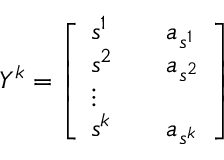<formula> <loc_0><loc_0><loc_500><loc_500>\begin{array} { r } { Y ^ { k } = \left [ \begin{array} { l l l } { s ^ { 1 } } & { a _ { s ^ { 1 } } } \\ { s ^ { 2 } } & { a _ { s ^ { 2 } } } \\ { \vdots } \\ { s ^ { k } } & { a _ { s ^ { k } } } \end{array} \right ] } \end{array}</formula> 